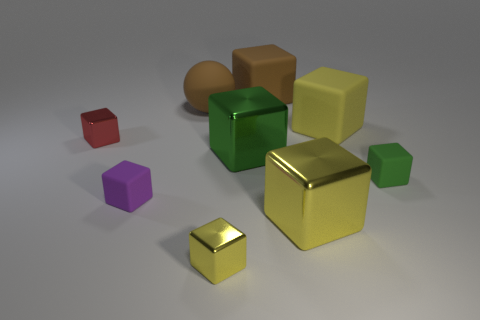Subtract all small green blocks. How many blocks are left? 7 Subtract all balls. How many objects are left? 8 Subtract all green cubes. How many cubes are left? 6 Add 1 tiny red metal cubes. How many objects exist? 10 Subtract 1 cubes. How many cubes are left? 7 Subtract all cyan cylinders. How many green blocks are left? 2 Subtract all brown metallic cubes. Subtract all small red things. How many objects are left? 8 Add 3 green cubes. How many green cubes are left? 5 Add 9 small metallic cylinders. How many small metallic cylinders exist? 9 Subtract 1 brown spheres. How many objects are left? 8 